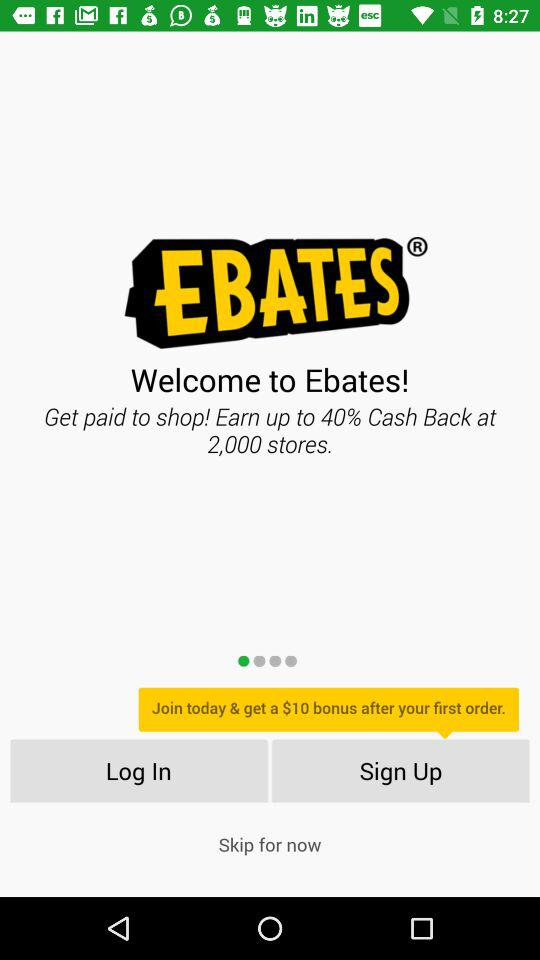At how many stores is the cash back available? The cash back is available at 2000 stores. 